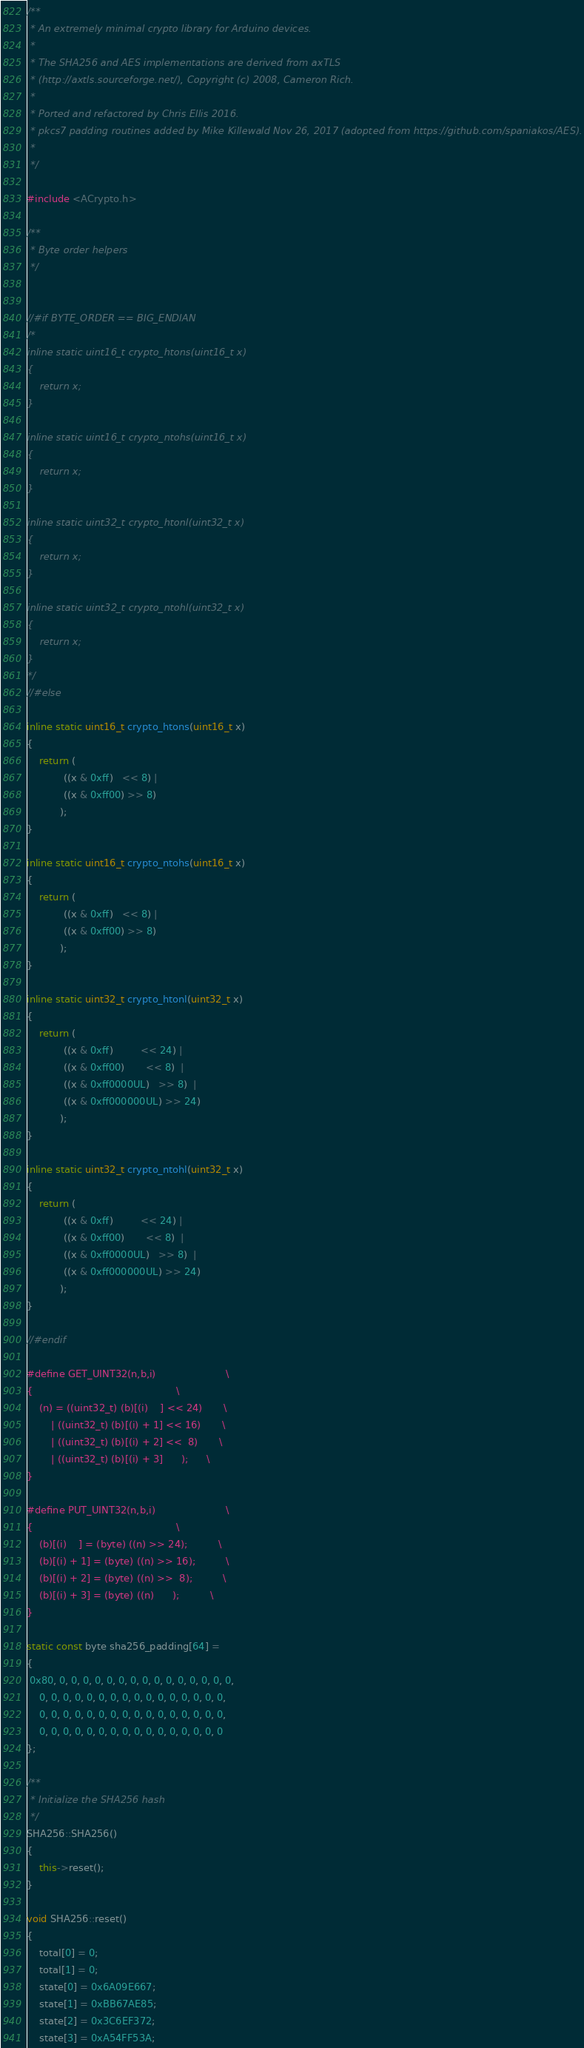Convert code to text. <code><loc_0><loc_0><loc_500><loc_500><_C++_>/**
 * An extremely minimal crypto library for Arduino devices.
 *
 * The SHA256 and AES implementations are derived from axTLS
 * (http://axtls.sourceforge.net/), Copyright (c) 2008, Cameron Rich.
 *
 * Ported and refactored by Chris Ellis 2016.
 * pkcs7 padding routines added by Mike Killewald Nov 26, 2017 (adopted from https://github.com/spaniakos/AES).
 *
 */

#include <ACrypto.h>

/**
 * Byte order helpers
 */


//#if BYTE_ORDER == BIG_ENDIAN
/*
inline static uint16_t crypto_htons(uint16_t x)
{
    return x;
}

inline static uint16_t crypto_ntohs(uint16_t x)
{
    return x;
}

inline static uint32_t crypto_htonl(uint32_t x)
{
    return x;
}

inline static uint32_t crypto_ntohl(uint32_t x)
{
    return x;
}
*/
//#else

inline static uint16_t crypto_htons(uint16_t x)
{
    return (
            ((x & 0xff)   << 8) |
            ((x & 0xff00) >> 8)
           );
}

inline static uint16_t crypto_ntohs(uint16_t x)
{
    return (
            ((x & 0xff)   << 8) |
            ((x & 0xff00) >> 8)
           );
}

inline static uint32_t crypto_htonl(uint32_t x)
{
    return (
            ((x & 0xff)         << 24) |
            ((x & 0xff00)       << 8)  |
            ((x & 0xff0000UL)   >> 8)  |
            ((x & 0xff000000UL) >> 24)
           );
}

inline static uint32_t crypto_ntohl(uint32_t x)
{
    return (
            ((x & 0xff)         << 24) |
            ((x & 0xff00)       << 8)  |
            ((x & 0xff0000UL)   >> 8)  |
            ((x & 0xff000000UL) >> 24)
           );
}

//#endif

#define GET_UINT32(n,b,i)                       \
{                                               \
    (n) = ((uint32_t) (b)[(i)    ] << 24)       \
        | ((uint32_t) (b)[(i) + 1] << 16)       \
        | ((uint32_t) (b)[(i) + 2] <<  8)       \
        | ((uint32_t) (b)[(i) + 3]      );      \
}

#define PUT_UINT32(n,b,i)                       \
{                                               \
    (b)[(i)    ] = (byte) ((n) >> 24);          \
    (b)[(i) + 1] = (byte) ((n) >> 16);          \
    (b)[(i) + 2] = (byte) ((n) >>  8);          \
    (b)[(i) + 3] = (byte) ((n)      );          \
}

static const byte sha256_padding[64] =
{
 0x80, 0, 0, 0, 0, 0, 0, 0, 0, 0, 0, 0, 0, 0, 0, 0,
    0, 0, 0, 0, 0, 0, 0, 0, 0, 0, 0, 0, 0, 0, 0, 0,
    0, 0, 0, 0, 0, 0, 0, 0, 0, 0, 0, 0, 0, 0, 0, 0,
    0, 0, 0, 0, 0, 0, 0, 0, 0, 0, 0, 0, 0, 0, 0, 0
};

/**
 * Initialize the SHA256 hash
 */
SHA256::SHA256()
{
    this->reset();
}

void SHA256::reset()
{
    total[0] = 0;
    total[1] = 0;
    state[0] = 0x6A09E667;
    state[1] = 0xBB67AE85;
    state[2] = 0x3C6EF372;
    state[3] = 0xA54FF53A;</code> 